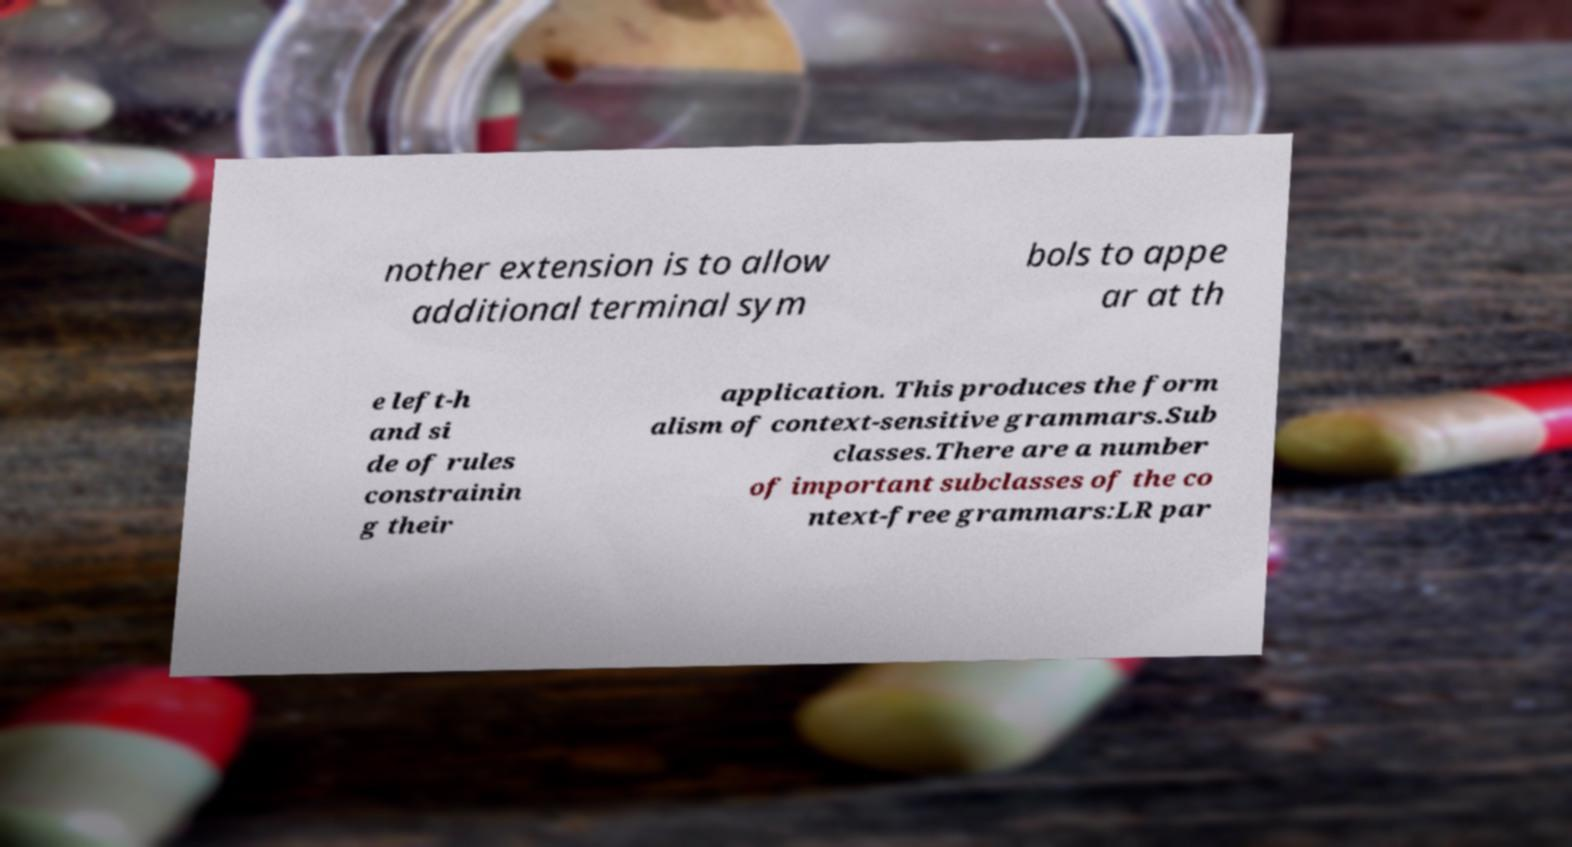I need the written content from this picture converted into text. Can you do that? nother extension is to allow additional terminal sym bols to appe ar at th e left-h and si de of rules constrainin g their application. This produces the form alism of context-sensitive grammars.Sub classes.There are a number of important subclasses of the co ntext-free grammars:LR par 